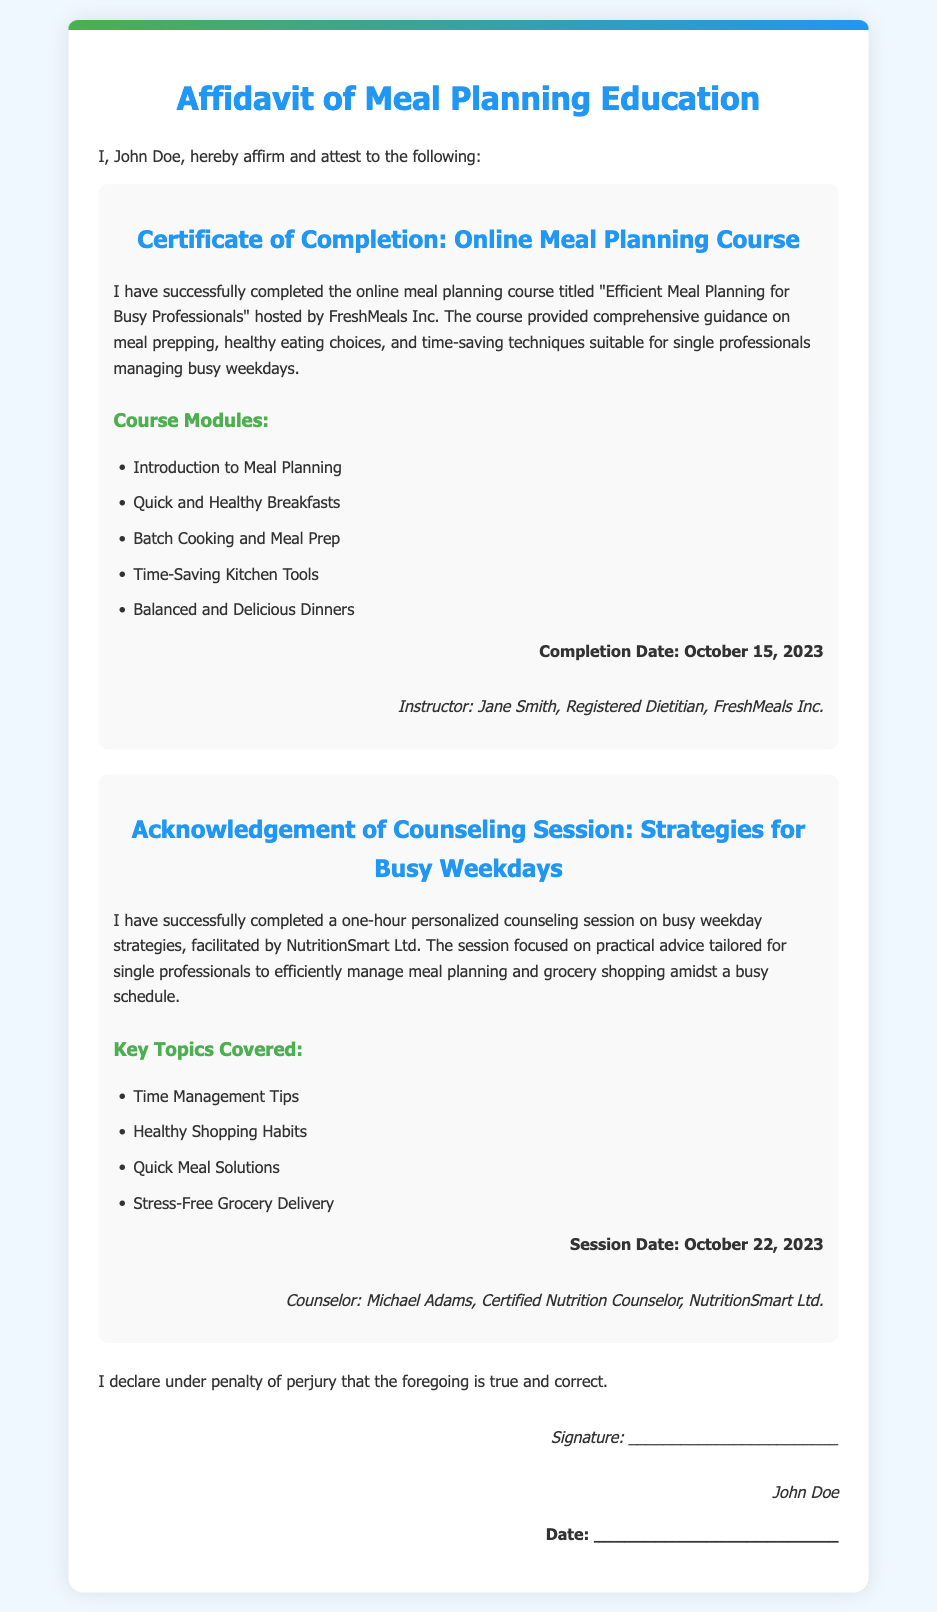What is the name of the course completed? The course completed is titled "Efficient Meal Planning for Busy Professionals."
Answer: "Efficient Meal Planning for Busy Professionals" Who is the registered dietitian listed in the document? The registered dietitian mentioned is Jane Smith.
Answer: Jane Smith What is the completion date of the meal planning course? The completion date of the meal planning course is October 15, 2023.
Answer: October 15, 2023 What organization facilitated the counseling session? The counseling session was facilitated by NutritionSmart Ltd.
Answer: NutritionSmart Ltd How long was the counseling session on busy weekday strategies? The counseling session lasted one hour.
Answer: one hour What are two key topics covered in the counseling session? Two key topics are "Healthy Shopping Habits" and "Quick Meal Solutions."
Answer: "Healthy Shopping Habits" and "Quick Meal Solutions" Who is the counselor mentioned in the document? The counselor mentioned is Michael Adams.
Answer: Michael Adams What is the session date for the counseling session? The session date for the counseling session is October 22, 2023.
Answer: October 22, 2023 